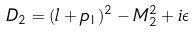Convert formula to latex. <formula><loc_0><loc_0><loc_500><loc_500>D _ { 2 } = ( l + p _ { 1 } ) ^ { 2 } - M ^ { 2 } _ { 2 } + i \epsilon</formula> 